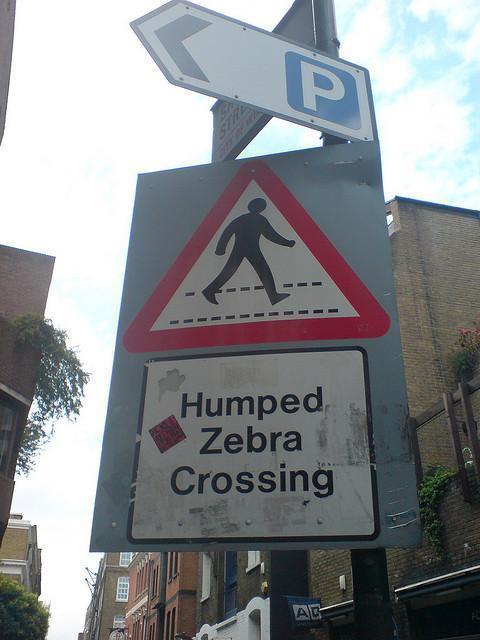How many signs are there?
Give a very brief answer. 3. How many signs are connected?
Give a very brief answer. 3. How many Pedestrian icons are there in that picture?
Give a very brief answer. 1. 